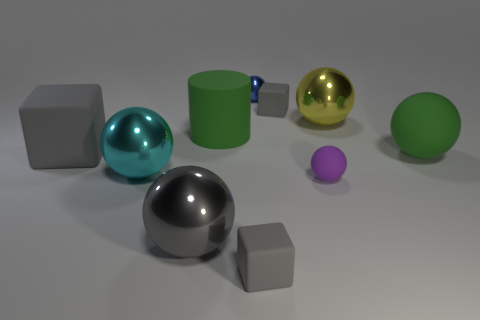What is the material of the ball that is the same color as the big rubber cube?
Your response must be concise. Metal. There is a cyan thing that is the same shape as the large yellow object; what is its size?
Provide a succinct answer. Large. Is the tiny gray block in front of the big yellow metallic object made of the same material as the small gray cube to the right of the blue metallic thing?
Ensure brevity in your answer.  Yes. Are there fewer gray spheres behind the big gray matte object than large shiny balls?
Your response must be concise. Yes. Are there any other things that have the same shape as the tiny purple matte object?
Your answer should be compact. Yes. There is another tiny rubber object that is the same shape as the cyan thing; what color is it?
Offer a very short reply. Purple. Do the green matte object that is right of the purple rubber ball and the big green cylinder have the same size?
Your answer should be compact. Yes. There is a green rubber sphere on the right side of the metal sphere that is right of the purple rubber thing; what size is it?
Provide a short and direct response. Large. Is the small blue object made of the same material as the cube in front of the big rubber ball?
Your response must be concise. No. Are there fewer big things in front of the cylinder than matte cubes that are to the left of the big cyan metallic thing?
Provide a short and direct response. No. 